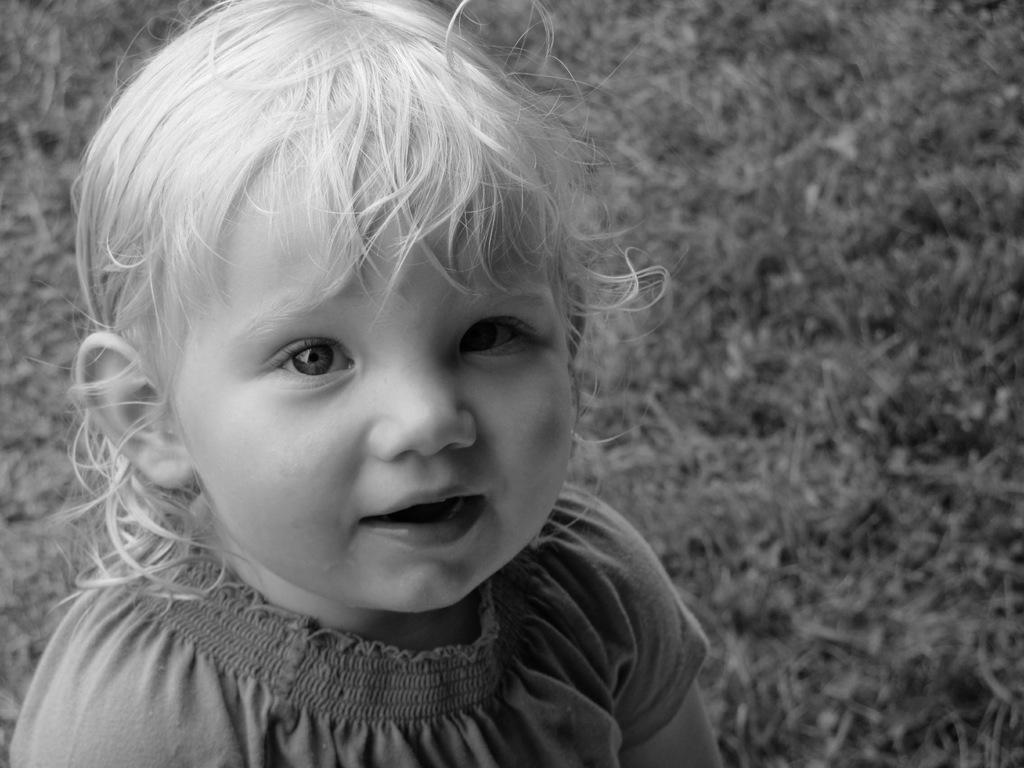What is the main subject of the image? The main subject of the image is a kid. What is the kid doing in the image? The kid is smiling in the image. What can be seen in the background of the image? The background of the image includes grass. What type of watch is the kid wearing in the image? There is no watch visible in the image; the kid is not wearing any accessories. 